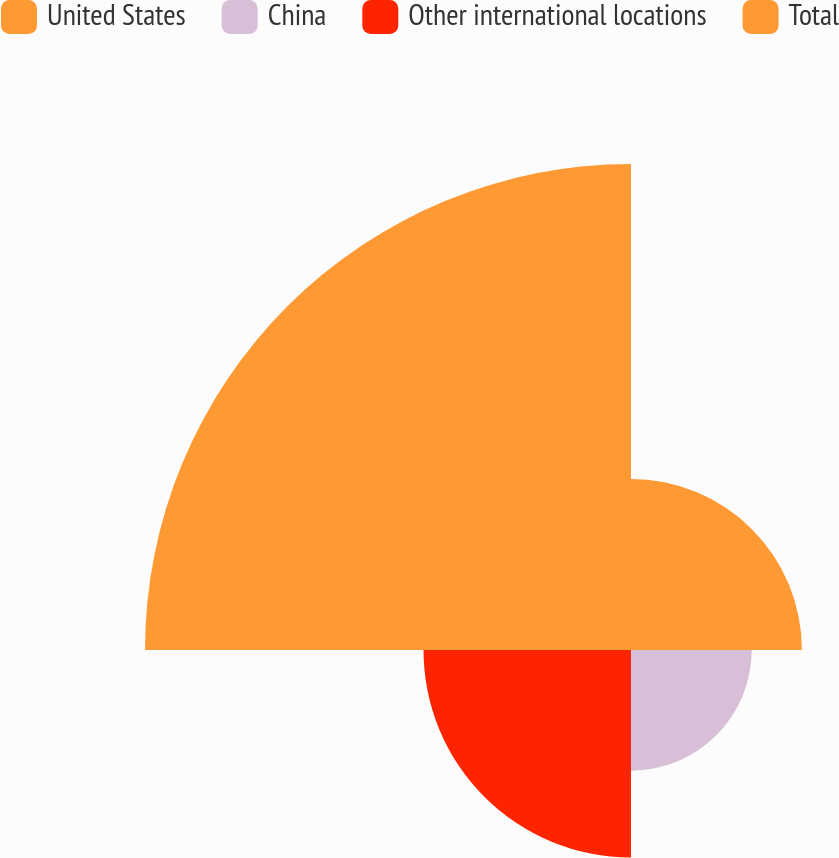<chart> <loc_0><loc_0><loc_500><loc_500><pie_chart><fcel>United States<fcel>China<fcel>Other international locations<fcel>Total<nl><fcel>17.35%<fcel>12.25%<fcel>21.06%<fcel>49.33%<nl></chart> 